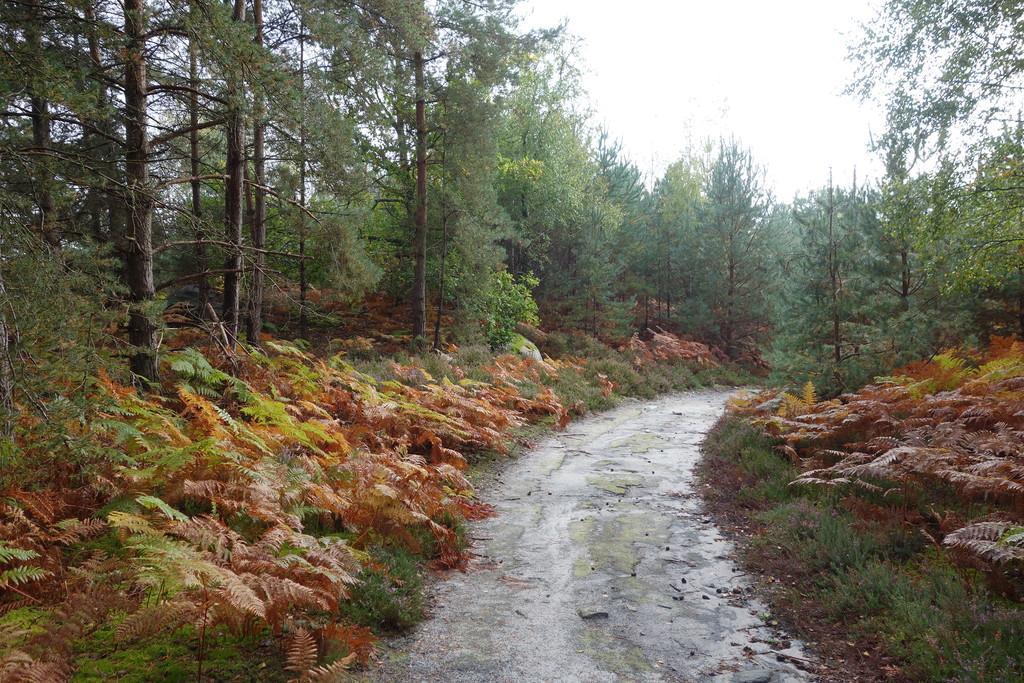Can you describe this image briefly? In this image I can see a empty road beside that there are so many plants, trees and grass. 